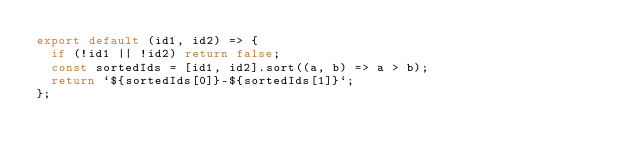Convert code to text. <code><loc_0><loc_0><loc_500><loc_500><_JavaScript_>export default (id1, id2) => {
  if (!id1 || !id2) return false;
  const sortedIds = [id1, id2].sort((a, b) => a > b);
  return `${sortedIds[0]}-${sortedIds[1]}`;
};
</code> 